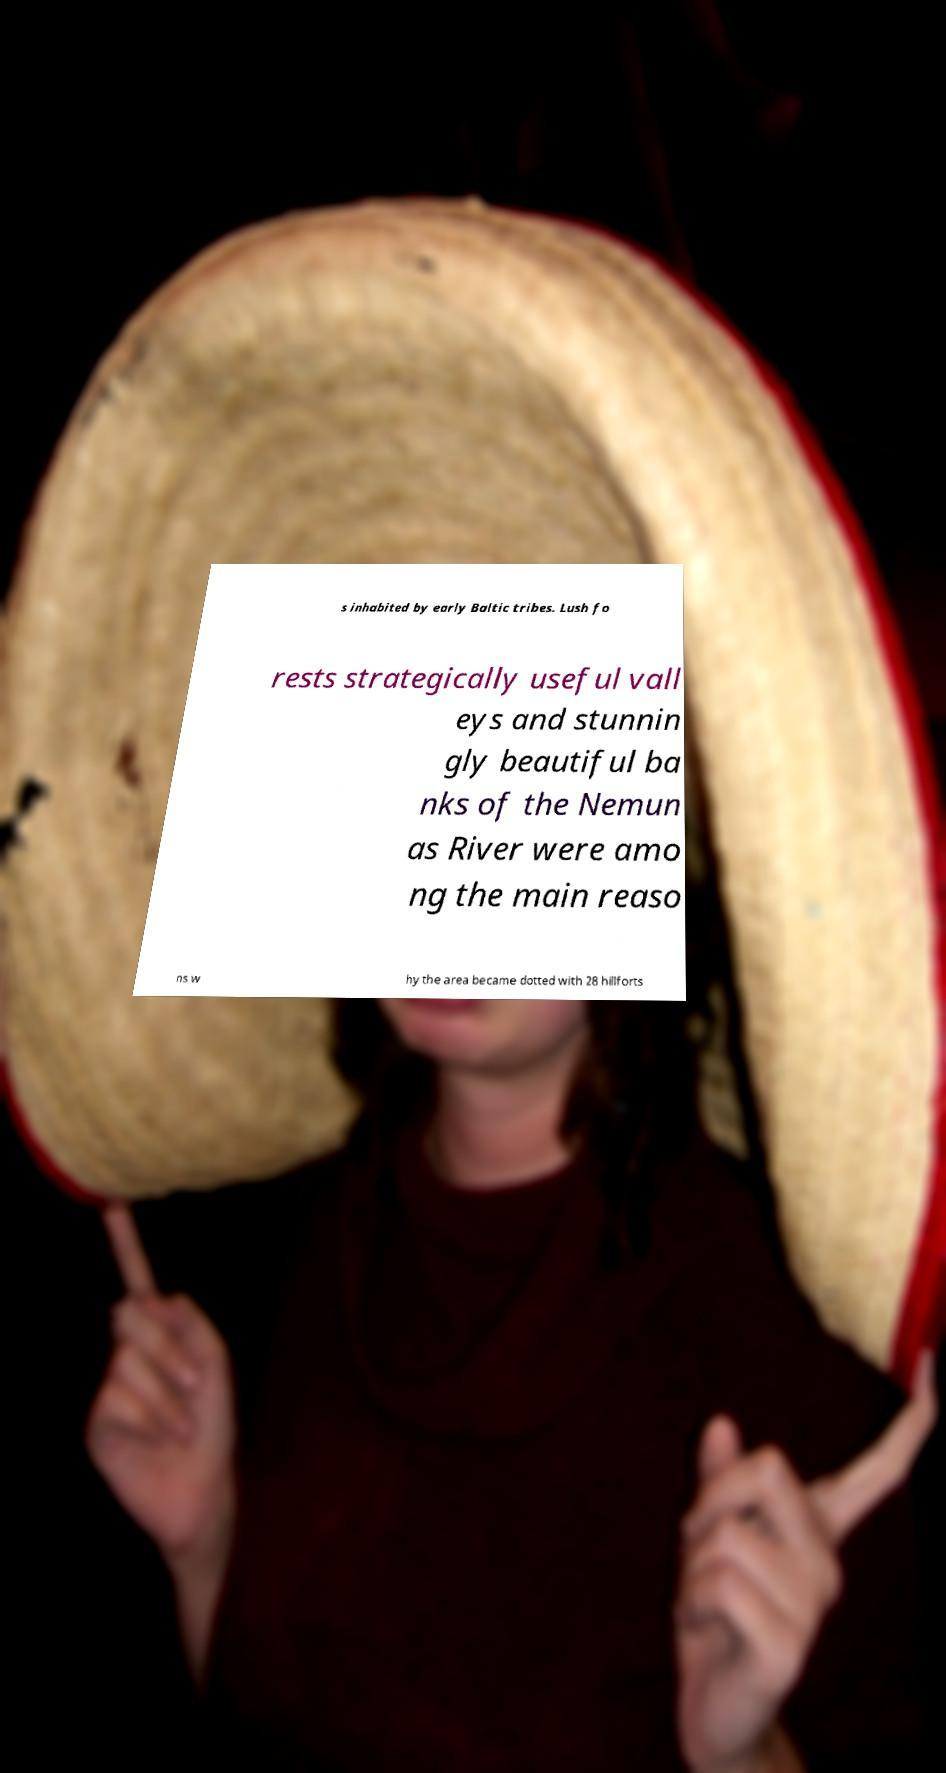I need the written content from this picture converted into text. Can you do that? s inhabited by early Baltic tribes. Lush fo rests strategically useful vall eys and stunnin gly beautiful ba nks of the Nemun as River were amo ng the main reaso ns w hy the area became dotted with 28 hillforts 